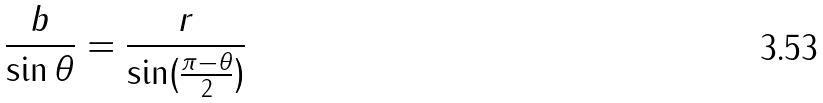<formula> <loc_0><loc_0><loc_500><loc_500>\frac { b } { \sin \theta } = \frac { r } { \sin ( \frac { \pi - \theta } { 2 } ) }</formula> 